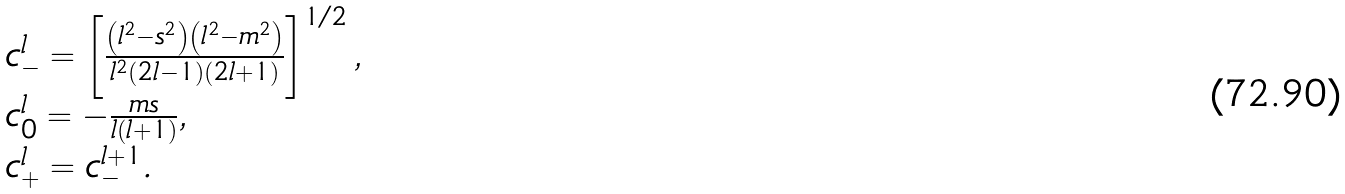Convert formula to latex. <formula><loc_0><loc_0><loc_500><loc_500>\begin{array} { l } c _ { - } ^ { l } = \left [ \frac { \left ( l ^ { 2 } - s ^ { 2 } \right ) \left ( l ^ { 2 } - m ^ { 2 } \right ) } { l ^ { 2 } ( 2 l - 1 ) ( 2 l + 1 ) } \right ] ^ { 1 / 2 } , \\ c _ { 0 } ^ { l } = - \frac { m s } { l ( l + 1 ) } , \\ c _ { + } ^ { l } = c _ { - } ^ { l + 1 } . \end{array}</formula> 